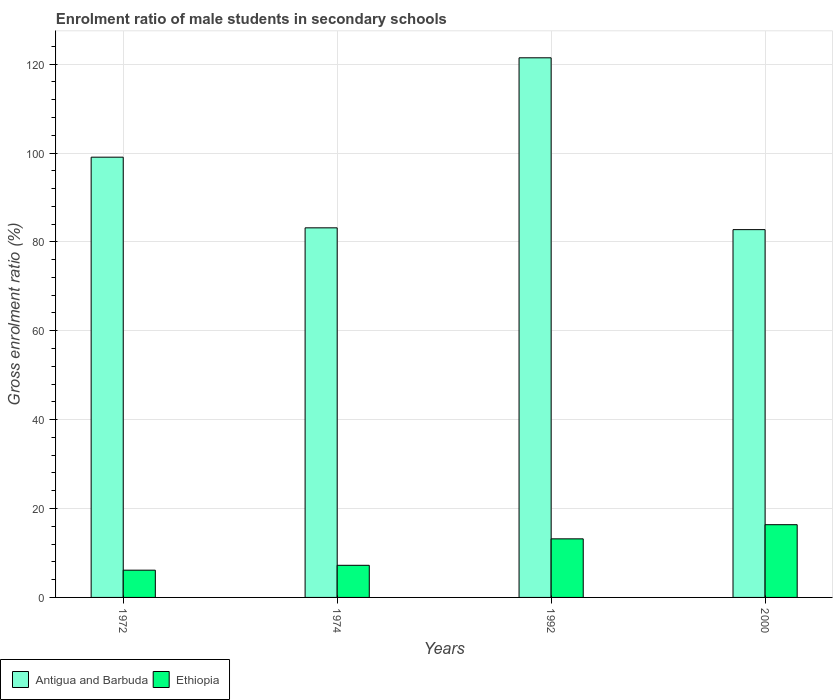How many bars are there on the 4th tick from the left?
Your answer should be very brief. 2. How many bars are there on the 1st tick from the right?
Your response must be concise. 2. What is the label of the 2nd group of bars from the left?
Offer a terse response. 1974. What is the enrolment ratio of male students in secondary schools in Antigua and Barbuda in 1974?
Give a very brief answer. 83.16. Across all years, what is the maximum enrolment ratio of male students in secondary schools in Antigua and Barbuda?
Your response must be concise. 121.42. Across all years, what is the minimum enrolment ratio of male students in secondary schools in Ethiopia?
Offer a very short reply. 6.13. In which year was the enrolment ratio of male students in secondary schools in Antigua and Barbuda minimum?
Provide a short and direct response. 2000. What is the total enrolment ratio of male students in secondary schools in Antigua and Barbuda in the graph?
Provide a short and direct response. 386.39. What is the difference between the enrolment ratio of male students in secondary schools in Antigua and Barbuda in 1972 and that in 1992?
Ensure brevity in your answer.  -22.36. What is the difference between the enrolment ratio of male students in secondary schools in Ethiopia in 1992 and the enrolment ratio of male students in secondary schools in Antigua and Barbuda in 1974?
Offer a very short reply. -69.98. What is the average enrolment ratio of male students in secondary schools in Antigua and Barbuda per year?
Give a very brief answer. 96.6. In the year 1972, what is the difference between the enrolment ratio of male students in secondary schools in Antigua and Barbuda and enrolment ratio of male students in secondary schools in Ethiopia?
Keep it short and to the point. 92.93. What is the ratio of the enrolment ratio of male students in secondary schools in Ethiopia in 1974 to that in 2000?
Your answer should be compact. 0.44. What is the difference between the highest and the second highest enrolment ratio of male students in secondary schools in Ethiopia?
Offer a very short reply. 3.19. What is the difference between the highest and the lowest enrolment ratio of male students in secondary schools in Ethiopia?
Keep it short and to the point. 10.23. In how many years, is the enrolment ratio of male students in secondary schools in Antigua and Barbuda greater than the average enrolment ratio of male students in secondary schools in Antigua and Barbuda taken over all years?
Give a very brief answer. 2. Is the sum of the enrolment ratio of male students in secondary schools in Antigua and Barbuda in 1972 and 1992 greater than the maximum enrolment ratio of male students in secondary schools in Ethiopia across all years?
Your answer should be very brief. Yes. What does the 2nd bar from the left in 1974 represents?
Your response must be concise. Ethiopia. What does the 2nd bar from the right in 1972 represents?
Offer a very short reply. Antigua and Barbuda. How many bars are there?
Your response must be concise. 8. Are all the bars in the graph horizontal?
Your answer should be compact. No. How many years are there in the graph?
Make the answer very short. 4. Does the graph contain any zero values?
Your answer should be compact. No. How many legend labels are there?
Ensure brevity in your answer.  2. What is the title of the graph?
Make the answer very short. Enrolment ratio of male students in secondary schools. What is the label or title of the X-axis?
Keep it short and to the point. Years. What is the Gross enrolment ratio (%) of Antigua and Barbuda in 1972?
Provide a short and direct response. 99.06. What is the Gross enrolment ratio (%) in Ethiopia in 1972?
Ensure brevity in your answer.  6.13. What is the Gross enrolment ratio (%) in Antigua and Barbuda in 1974?
Provide a short and direct response. 83.16. What is the Gross enrolment ratio (%) of Ethiopia in 1974?
Keep it short and to the point. 7.23. What is the Gross enrolment ratio (%) in Antigua and Barbuda in 1992?
Provide a short and direct response. 121.42. What is the Gross enrolment ratio (%) in Ethiopia in 1992?
Your answer should be compact. 13.18. What is the Gross enrolment ratio (%) of Antigua and Barbuda in 2000?
Make the answer very short. 82.76. What is the Gross enrolment ratio (%) in Ethiopia in 2000?
Provide a succinct answer. 16.37. Across all years, what is the maximum Gross enrolment ratio (%) in Antigua and Barbuda?
Make the answer very short. 121.42. Across all years, what is the maximum Gross enrolment ratio (%) in Ethiopia?
Your response must be concise. 16.37. Across all years, what is the minimum Gross enrolment ratio (%) in Antigua and Barbuda?
Offer a very short reply. 82.76. Across all years, what is the minimum Gross enrolment ratio (%) in Ethiopia?
Keep it short and to the point. 6.13. What is the total Gross enrolment ratio (%) of Antigua and Barbuda in the graph?
Make the answer very short. 386.39. What is the total Gross enrolment ratio (%) in Ethiopia in the graph?
Your answer should be compact. 42.91. What is the difference between the Gross enrolment ratio (%) in Antigua and Barbuda in 1972 and that in 1974?
Your answer should be very brief. 15.9. What is the difference between the Gross enrolment ratio (%) of Ethiopia in 1972 and that in 1974?
Offer a terse response. -1.1. What is the difference between the Gross enrolment ratio (%) in Antigua and Barbuda in 1972 and that in 1992?
Your response must be concise. -22.36. What is the difference between the Gross enrolment ratio (%) in Ethiopia in 1972 and that in 1992?
Keep it short and to the point. -7.05. What is the difference between the Gross enrolment ratio (%) of Antigua and Barbuda in 1972 and that in 2000?
Make the answer very short. 16.3. What is the difference between the Gross enrolment ratio (%) of Ethiopia in 1972 and that in 2000?
Offer a very short reply. -10.23. What is the difference between the Gross enrolment ratio (%) in Antigua and Barbuda in 1974 and that in 1992?
Your answer should be compact. -38.26. What is the difference between the Gross enrolment ratio (%) in Ethiopia in 1974 and that in 1992?
Offer a very short reply. -5.95. What is the difference between the Gross enrolment ratio (%) in Antigua and Barbuda in 1974 and that in 2000?
Keep it short and to the point. 0.4. What is the difference between the Gross enrolment ratio (%) of Ethiopia in 1974 and that in 2000?
Provide a succinct answer. -9.14. What is the difference between the Gross enrolment ratio (%) in Antigua and Barbuda in 1992 and that in 2000?
Provide a short and direct response. 38.66. What is the difference between the Gross enrolment ratio (%) in Ethiopia in 1992 and that in 2000?
Give a very brief answer. -3.19. What is the difference between the Gross enrolment ratio (%) in Antigua and Barbuda in 1972 and the Gross enrolment ratio (%) in Ethiopia in 1974?
Your answer should be compact. 91.83. What is the difference between the Gross enrolment ratio (%) in Antigua and Barbuda in 1972 and the Gross enrolment ratio (%) in Ethiopia in 1992?
Make the answer very short. 85.88. What is the difference between the Gross enrolment ratio (%) of Antigua and Barbuda in 1972 and the Gross enrolment ratio (%) of Ethiopia in 2000?
Keep it short and to the point. 82.69. What is the difference between the Gross enrolment ratio (%) in Antigua and Barbuda in 1974 and the Gross enrolment ratio (%) in Ethiopia in 1992?
Ensure brevity in your answer.  69.98. What is the difference between the Gross enrolment ratio (%) in Antigua and Barbuda in 1974 and the Gross enrolment ratio (%) in Ethiopia in 2000?
Offer a very short reply. 66.79. What is the difference between the Gross enrolment ratio (%) in Antigua and Barbuda in 1992 and the Gross enrolment ratio (%) in Ethiopia in 2000?
Offer a very short reply. 105.05. What is the average Gross enrolment ratio (%) in Antigua and Barbuda per year?
Keep it short and to the point. 96.6. What is the average Gross enrolment ratio (%) of Ethiopia per year?
Ensure brevity in your answer.  10.73. In the year 1972, what is the difference between the Gross enrolment ratio (%) in Antigua and Barbuda and Gross enrolment ratio (%) in Ethiopia?
Keep it short and to the point. 92.93. In the year 1974, what is the difference between the Gross enrolment ratio (%) of Antigua and Barbuda and Gross enrolment ratio (%) of Ethiopia?
Give a very brief answer. 75.93. In the year 1992, what is the difference between the Gross enrolment ratio (%) in Antigua and Barbuda and Gross enrolment ratio (%) in Ethiopia?
Provide a short and direct response. 108.24. In the year 2000, what is the difference between the Gross enrolment ratio (%) in Antigua and Barbuda and Gross enrolment ratio (%) in Ethiopia?
Offer a terse response. 66.39. What is the ratio of the Gross enrolment ratio (%) in Antigua and Barbuda in 1972 to that in 1974?
Ensure brevity in your answer.  1.19. What is the ratio of the Gross enrolment ratio (%) of Ethiopia in 1972 to that in 1974?
Provide a short and direct response. 0.85. What is the ratio of the Gross enrolment ratio (%) of Antigua and Barbuda in 1972 to that in 1992?
Your answer should be very brief. 0.82. What is the ratio of the Gross enrolment ratio (%) in Ethiopia in 1972 to that in 1992?
Provide a short and direct response. 0.47. What is the ratio of the Gross enrolment ratio (%) in Antigua and Barbuda in 1972 to that in 2000?
Give a very brief answer. 1.2. What is the ratio of the Gross enrolment ratio (%) in Ethiopia in 1972 to that in 2000?
Provide a short and direct response. 0.37. What is the ratio of the Gross enrolment ratio (%) of Antigua and Barbuda in 1974 to that in 1992?
Make the answer very short. 0.68. What is the ratio of the Gross enrolment ratio (%) in Ethiopia in 1974 to that in 1992?
Your answer should be very brief. 0.55. What is the ratio of the Gross enrolment ratio (%) in Ethiopia in 1974 to that in 2000?
Offer a terse response. 0.44. What is the ratio of the Gross enrolment ratio (%) in Antigua and Barbuda in 1992 to that in 2000?
Offer a terse response. 1.47. What is the ratio of the Gross enrolment ratio (%) of Ethiopia in 1992 to that in 2000?
Provide a succinct answer. 0.81. What is the difference between the highest and the second highest Gross enrolment ratio (%) in Antigua and Barbuda?
Your response must be concise. 22.36. What is the difference between the highest and the second highest Gross enrolment ratio (%) of Ethiopia?
Provide a short and direct response. 3.19. What is the difference between the highest and the lowest Gross enrolment ratio (%) in Antigua and Barbuda?
Your answer should be compact. 38.66. What is the difference between the highest and the lowest Gross enrolment ratio (%) of Ethiopia?
Offer a very short reply. 10.23. 